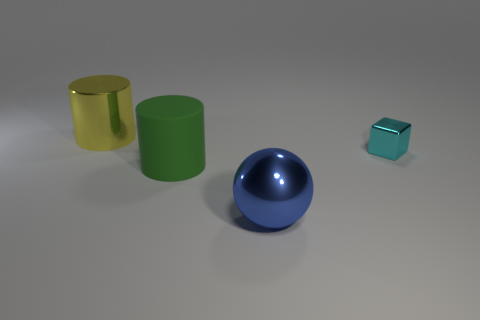There is a big metallic thing that is to the right of the big thing that is behind the shiny object that is on the right side of the blue object; what is its color?
Keep it short and to the point. Blue. Is the material of the large blue thing the same as the cube?
Your response must be concise. Yes. How many cyan things are either shiny cylinders or tiny metallic things?
Your response must be concise. 1. How many big green rubber cylinders are in front of the yellow metallic cylinder?
Give a very brief answer. 1. Is the number of big things greater than the number of things?
Make the answer very short. No. What shape is the big metal thing that is in front of the big cylinder right of the big yellow object?
Your answer should be very brief. Sphere. Is the number of big cylinders that are right of the big metallic cylinder greater than the number of large green rubber spheres?
Keep it short and to the point. Yes. There is a large shiny thing left of the large blue shiny thing; what number of big yellow objects are right of it?
Offer a very short reply. 0. Is the big yellow cylinder that is to the left of the big rubber object made of the same material as the cylinder that is in front of the big yellow object?
Make the answer very short. No. What number of other shiny things have the same shape as the blue metallic thing?
Your answer should be very brief. 0. 